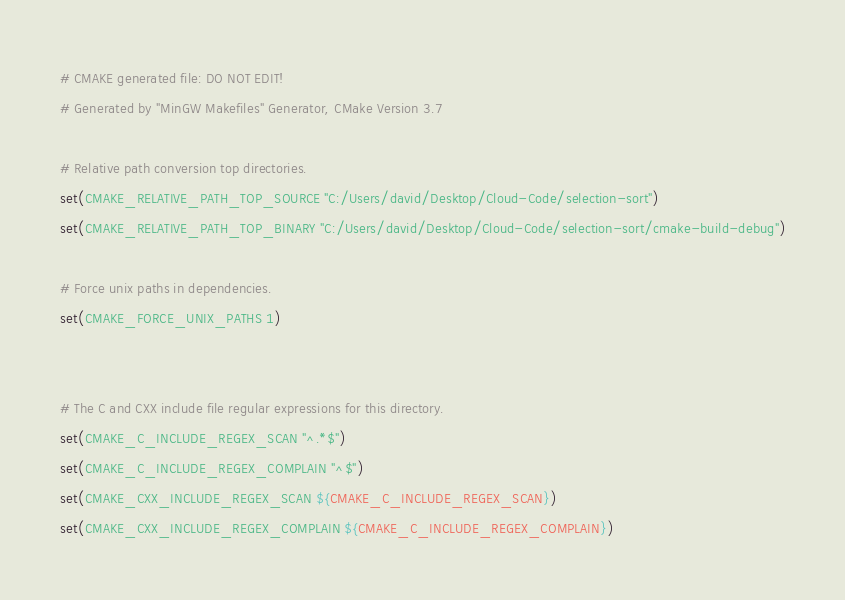Convert code to text. <code><loc_0><loc_0><loc_500><loc_500><_CMake_># CMAKE generated file: DO NOT EDIT!
# Generated by "MinGW Makefiles" Generator, CMake Version 3.7

# Relative path conversion top directories.
set(CMAKE_RELATIVE_PATH_TOP_SOURCE "C:/Users/david/Desktop/Cloud-Code/selection-sort")
set(CMAKE_RELATIVE_PATH_TOP_BINARY "C:/Users/david/Desktop/Cloud-Code/selection-sort/cmake-build-debug")

# Force unix paths in dependencies.
set(CMAKE_FORCE_UNIX_PATHS 1)


# The C and CXX include file regular expressions for this directory.
set(CMAKE_C_INCLUDE_REGEX_SCAN "^.*$")
set(CMAKE_C_INCLUDE_REGEX_COMPLAIN "^$")
set(CMAKE_CXX_INCLUDE_REGEX_SCAN ${CMAKE_C_INCLUDE_REGEX_SCAN})
set(CMAKE_CXX_INCLUDE_REGEX_COMPLAIN ${CMAKE_C_INCLUDE_REGEX_COMPLAIN})
</code> 